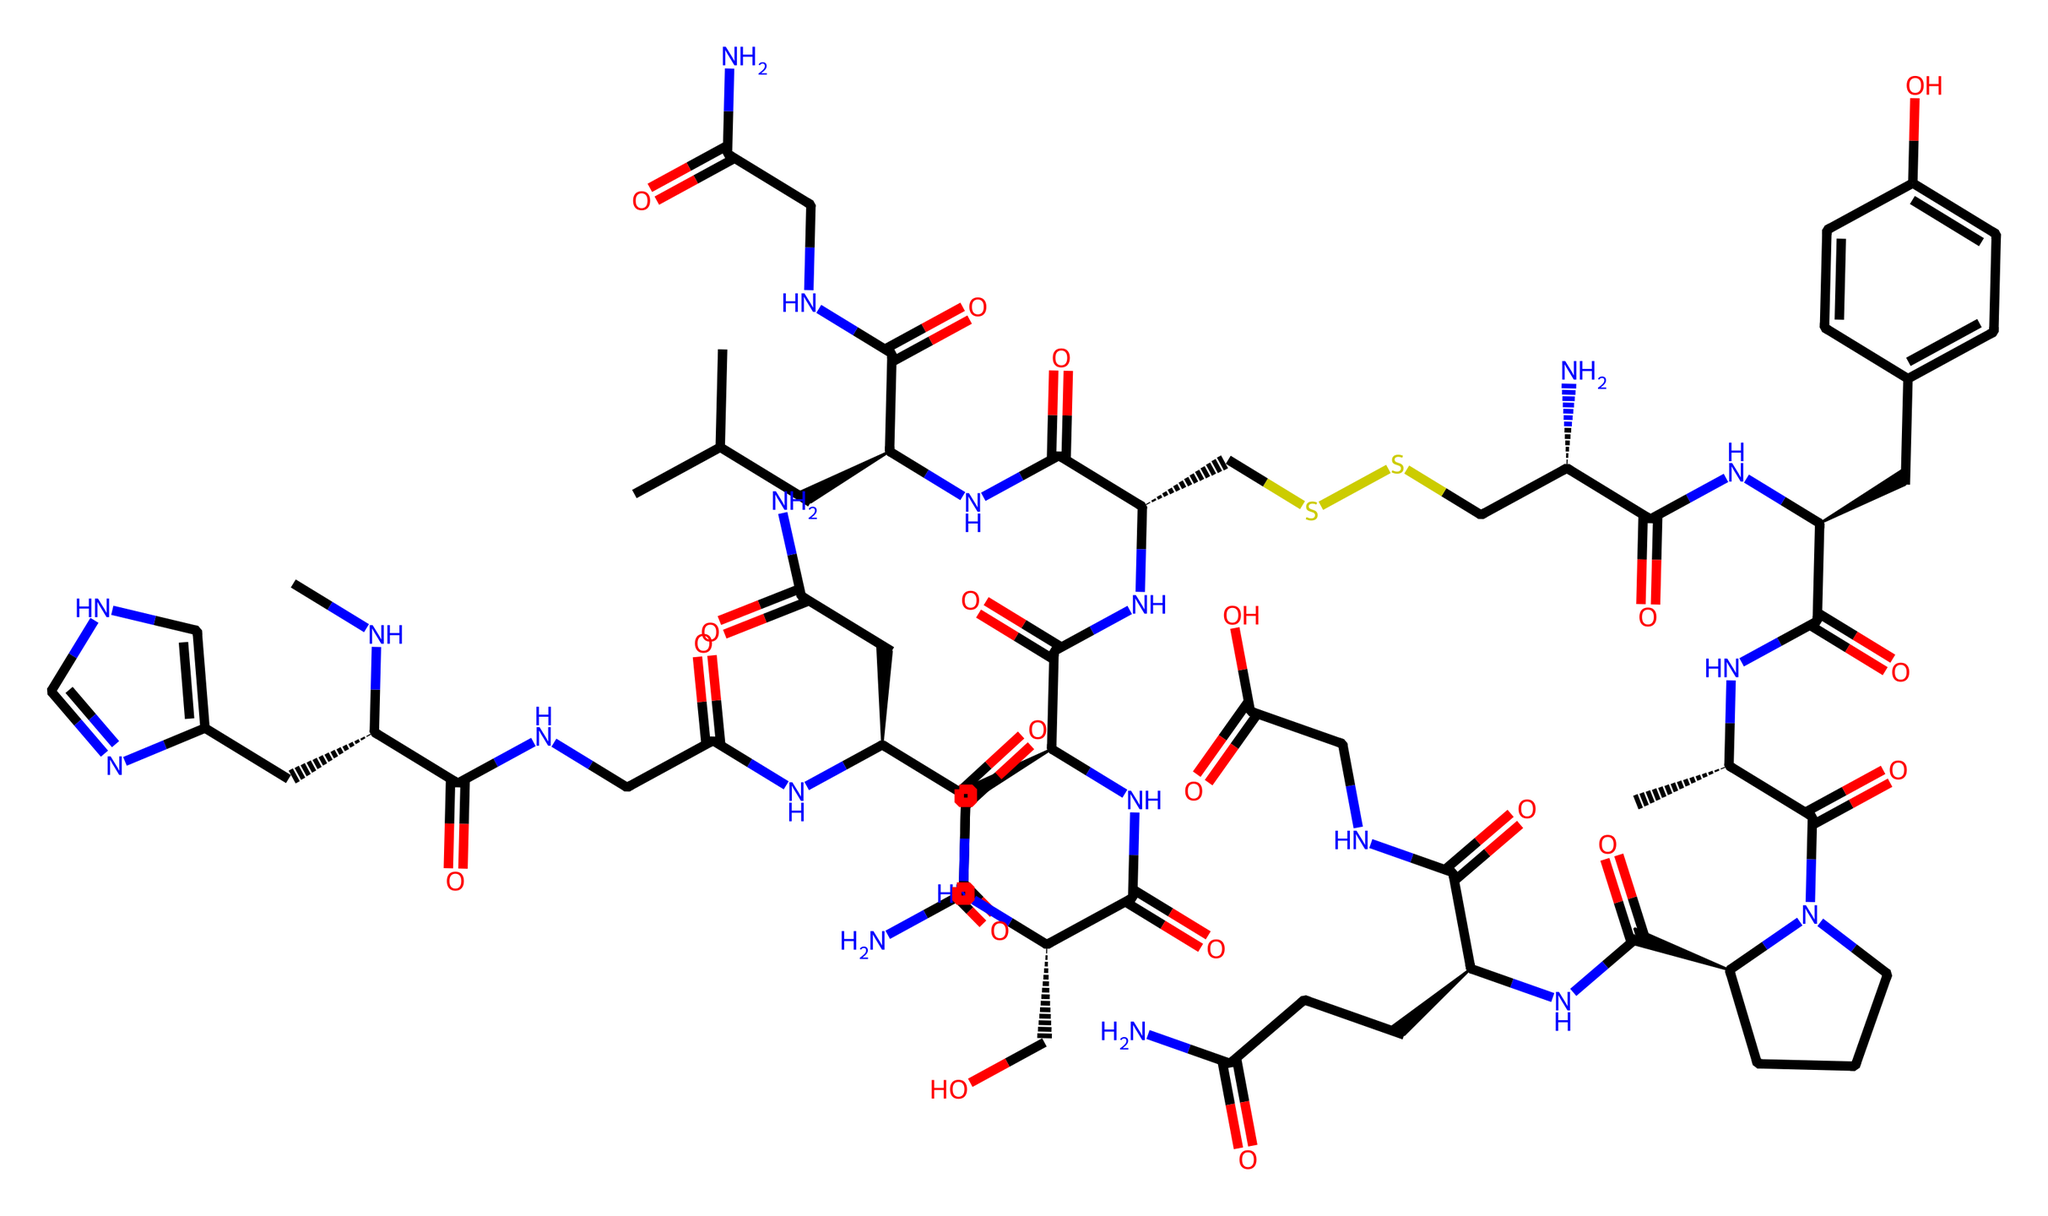What is the molecular formula of oxytocin? To determine the molecular formula, we can count the different types of atoms in the SMILES representation. We identify carbon (C), hydrogen (H), nitrogen (N), oxygen (O), and sulfur (S) atoms. The formula is compiled based on these counts: C43, H66, N12, O12, S2.
Answer: C43H66N12O12S2 How many chiral centers are present in oxytocin? By analyzing the SMILES, we note that chirality is indicated by "@", which shows that these are chiral centers. Counting these symbols, we find six chiral centers in the structure of oxytocin.
Answer: 6 What type of chemical is oxytocin classified as? Oxytocin is a peptide hormone, which is evident from the presence of multiple amide (C(=O)N) bonds in its structure, indicating it is composed of amino acids.
Answer: peptide hormone What functional groups are prominent in the oxytocin structure? Reviewing the SMILES, we see several key functional groups: amides due to C(=O)N, thiol due to S, and hydroxyl due to O. The presence of these groups is indicative of the chemical's functionality.
Answer: amides, thiol, hydroxyl How many rings are present in the oxytocin structure? By examining the SMILES notation, we look for any numbers labeled at specific atoms that indicate ring closures. The "CCC" notation typically shows cyclization, meaning there are two rings present in the structure of oxytocin.
Answer: 2 Which part of oxytocin is responsible for its interactions with receptors? The interaction with receptors is largely influenced by the peptide portions and specific functional groups present in oxytocin, particularly regions related to the amide bonds and chiral centers that would fit into receptor sites.
Answer: peptide portion Which atom is involved in the disulfide bond in oxytocin? Disulfide bonds are characterized by the presence of sulfur atoms connected by a single bond. In the SMILES, the "SS" notation indicates the presence of a disulfide bond, which involves two sulfur atoms.
Answer: sulfur 